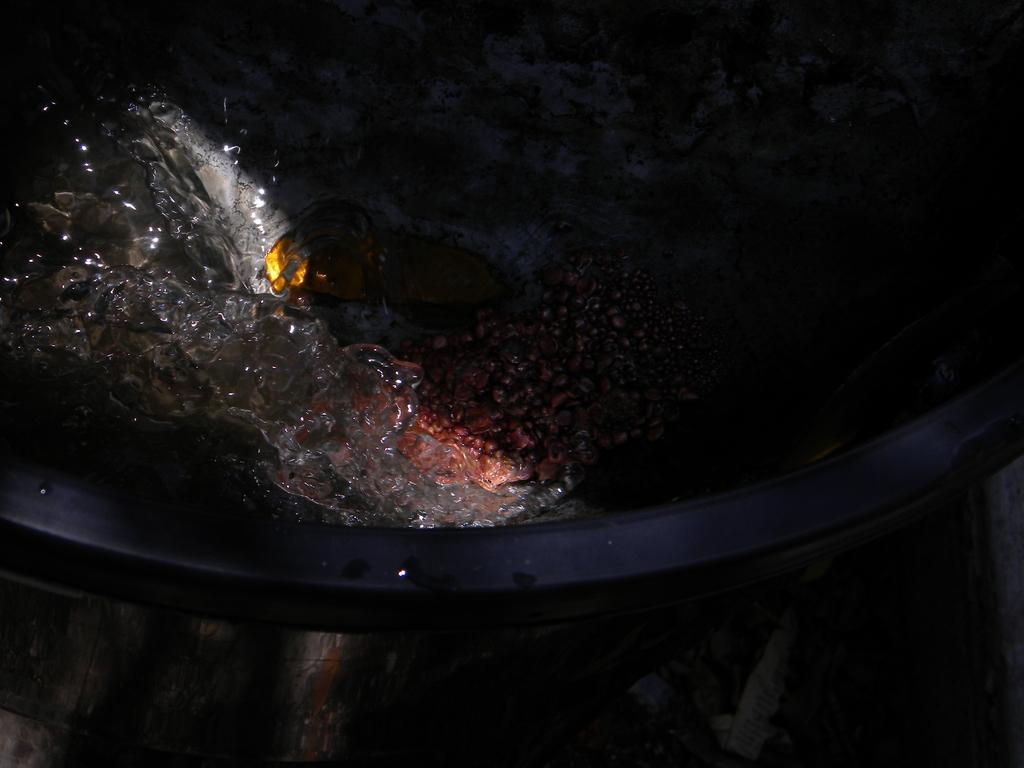What is the primary element visible in the image? There is water in the image. Is there anything else in the water besides the water itself? Yes, there is an object in the water. What can be seen beside the water in the image? There is a black surface beside the water. How many beggars can be seen in the image? There are no beggars present in the image. Is the water in the image covered in snow? There is no snow visible in the image; it only shows water and an object within it. What type of bird is sitting on the black surface beside the water? There is no bird, specifically a turkey, present in the image. 